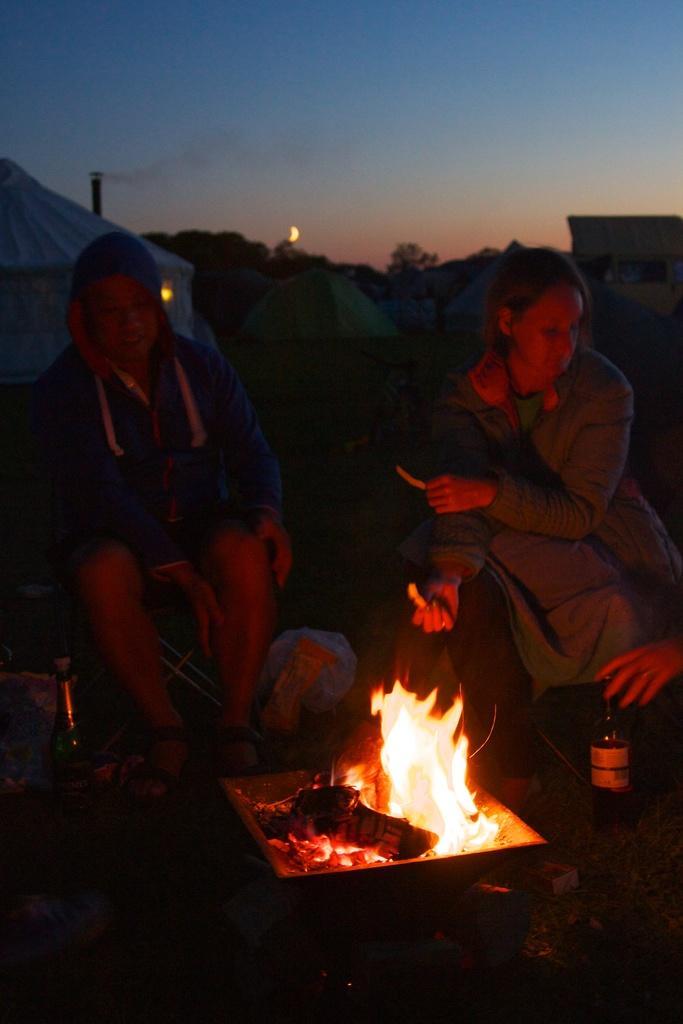Could you give a brief overview of what you see in this image? In this picture we can see few people, in front of them we can find few bottles and fire, in the background we can see few tents and trees. 